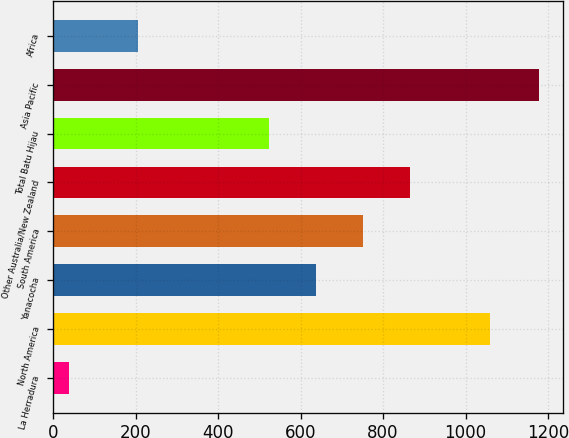Convert chart. <chart><loc_0><loc_0><loc_500><loc_500><bar_chart><fcel>La Herradura<fcel>North America<fcel>Yanacocha<fcel>South America<fcel>Other Australia/New Zealand<fcel>Total Batu Hijau<fcel>Asia Pacific<fcel>Africa<nl><fcel>38<fcel>1060<fcel>637<fcel>751<fcel>865<fcel>523<fcel>1178<fcel>205<nl></chart> 